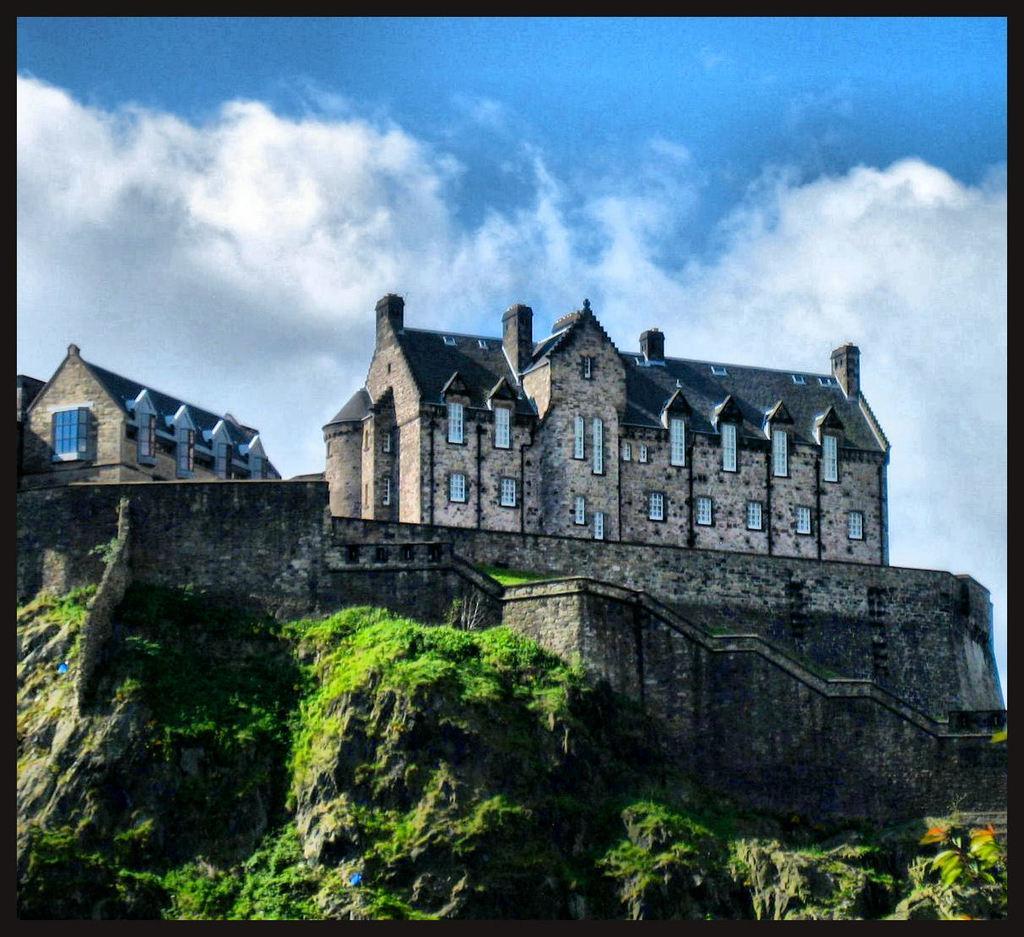Describe this image in one or two sentences. This image consists of a building along with windows and doors. At the bottom, there are mountains. At the top, there are clouds in the sky. 